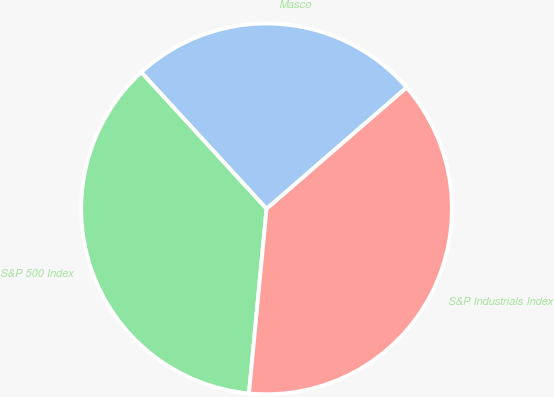Convert chart to OTSL. <chart><loc_0><loc_0><loc_500><loc_500><pie_chart><fcel>Masco<fcel>S&P 500 Index<fcel>S&P Industrials Index<nl><fcel>25.45%<fcel>36.67%<fcel>37.88%<nl></chart> 